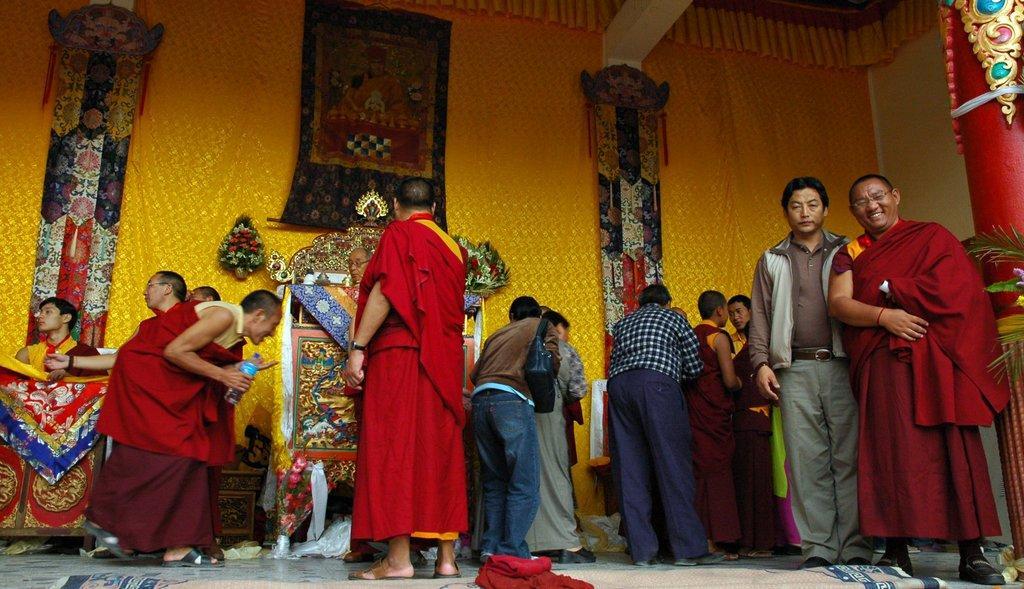Could you give a brief overview of what you see in this image? Here we can see group of people. This is floor and there is a carpet. In the background we can see curtain, flower bouquets, and banners. 